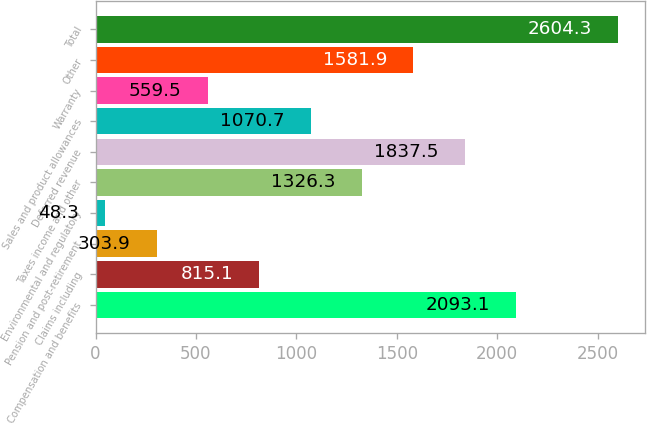<chart> <loc_0><loc_0><loc_500><loc_500><bar_chart><fcel>Compensation and benefits<fcel>Claims including<fcel>Pension and post-retirement<fcel>Environmental and regulatory<fcel>Taxes income and other<fcel>Deferred revenue<fcel>Sales and product allowances<fcel>Warranty<fcel>Other<fcel>Total<nl><fcel>2093.1<fcel>815.1<fcel>303.9<fcel>48.3<fcel>1326.3<fcel>1837.5<fcel>1070.7<fcel>559.5<fcel>1581.9<fcel>2604.3<nl></chart> 